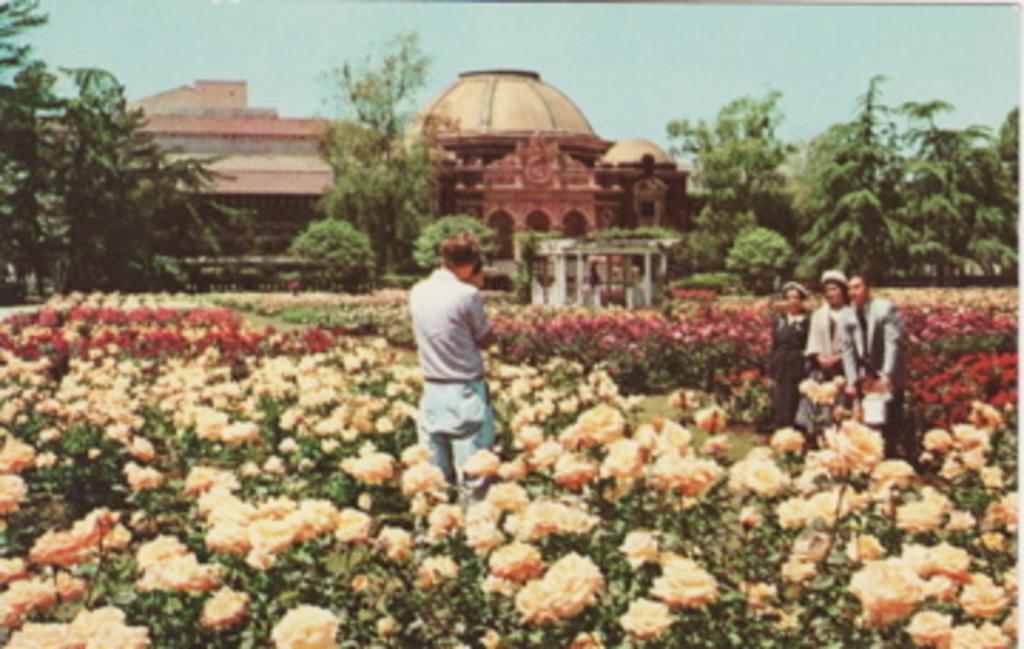Please provide a concise description of this image. This image looks like an edited photo, in which I can see four persons are standing on grass and I can see flowering plants in a farm. In the background, I can see buildings, trees, minarets and the sky. 